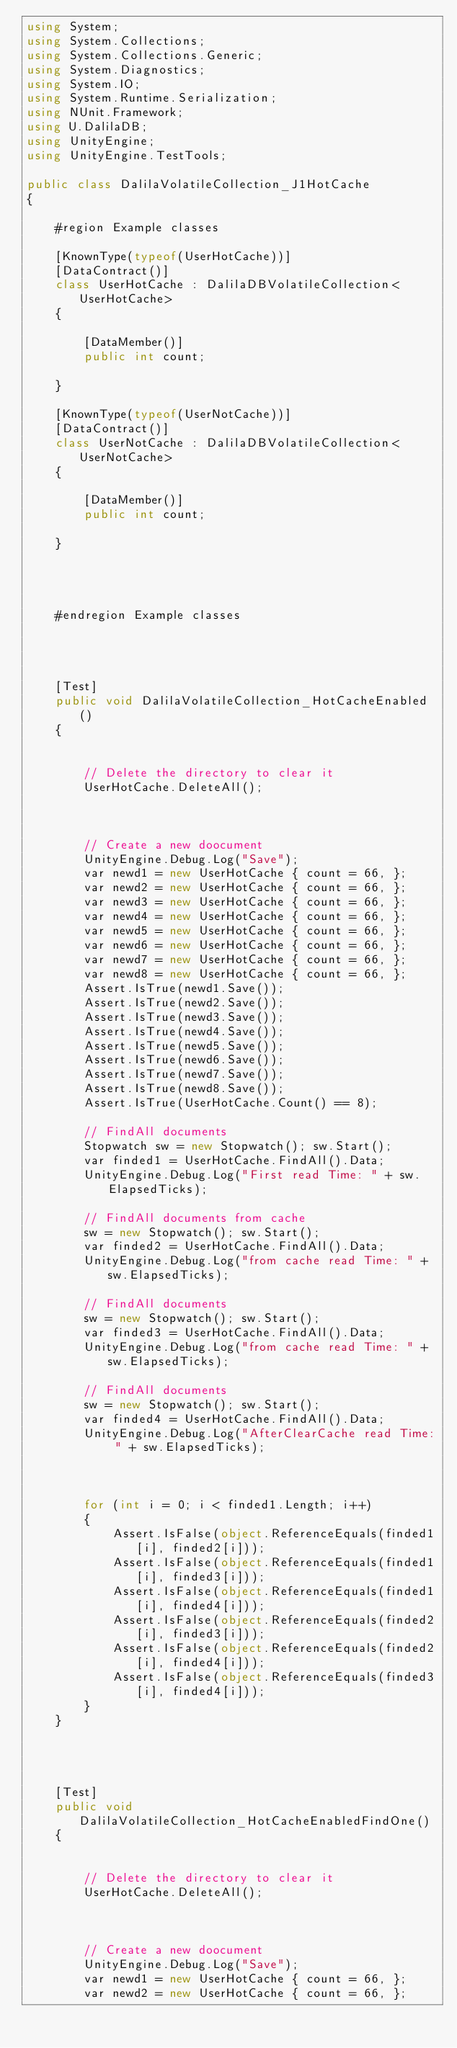<code> <loc_0><loc_0><loc_500><loc_500><_C#_>using System;
using System.Collections;
using System.Collections.Generic;
using System.Diagnostics;
using System.IO;
using System.Runtime.Serialization;
using NUnit.Framework;
using U.DalilaDB;
using UnityEngine;
using UnityEngine.TestTools;

public class DalilaVolatileCollection_J1HotCache
{

    #region Example classes

    [KnownType(typeof(UserHotCache))]
    [DataContract()]
    class UserHotCache : DalilaDBVolatileCollection<UserHotCache>
    {

        [DataMember()]
        public int count;

    }

    [KnownType(typeof(UserNotCache))]
    [DataContract()]
    class UserNotCache : DalilaDBVolatileCollection<UserNotCache>
    {

        [DataMember()]
        public int count;

    }




    #endregion Example classes




    [Test]
    public void DalilaVolatileCollection_HotCacheEnabled()
    {


        // Delete the directory to clear it
        UserHotCache.DeleteAll();



        // Create a new doocument
        UnityEngine.Debug.Log("Save");
        var newd1 = new UserHotCache { count = 66, };
        var newd2 = new UserHotCache { count = 66, };
        var newd3 = new UserHotCache { count = 66, };
        var newd4 = new UserHotCache { count = 66, };
        var newd5 = new UserHotCache { count = 66, };
        var newd6 = new UserHotCache { count = 66, };
        var newd7 = new UserHotCache { count = 66, };
        var newd8 = new UserHotCache { count = 66, };
        Assert.IsTrue(newd1.Save());
        Assert.IsTrue(newd2.Save());
        Assert.IsTrue(newd3.Save());
        Assert.IsTrue(newd4.Save());
        Assert.IsTrue(newd5.Save());
        Assert.IsTrue(newd6.Save());
        Assert.IsTrue(newd7.Save());
        Assert.IsTrue(newd8.Save());
        Assert.IsTrue(UserHotCache.Count() == 8);

        // FindAll documents
        Stopwatch sw = new Stopwatch(); sw.Start();
        var finded1 = UserHotCache.FindAll().Data;
        UnityEngine.Debug.Log("First read Time: " + sw.ElapsedTicks);

        // FindAll documents from cache
        sw = new Stopwatch(); sw.Start();
        var finded2 = UserHotCache.FindAll().Data;
        UnityEngine.Debug.Log("from cache read Time: " + sw.ElapsedTicks);

        // FindAll documents
        sw = new Stopwatch(); sw.Start();
        var finded3 = UserHotCache.FindAll().Data;
        UnityEngine.Debug.Log("from cache read Time: " + sw.ElapsedTicks);

        // FindAll documents
        sw = new Stopwatch(); sw.Start();
        var finded4 = UserHotCache.FindAll().Data;
        UnityEngine.Debug.Log("AfterClearCache read Time: " + sw.ElapsedTicks);



        for (int i = 0; i < finded1.Length; i++)
        {
            Assert.IsFalse(object.ReferenceEquals(finded1[i], finded2[i]));
            Assert.IsFalse(object.ReferenceEquals(finded1[i], finded3[i]));
            Assert.IsFalse(object.ReferenceEquals(finded1[i], finded4[i]));
            Assert.IsFalse(object.ReferenceEquals(finded2[i], finded3[i]));
            Assert.IsFalse(object.ReferenceEquals(finded2[i], finded4[i]));
            Assert.IsFalse(object.ReferenceEquals(finded3[i], finded4[i]));
        }
    }




    [Test]
    public void DalilaVolatileCollection_HotCacheEnabledFindOne()
    {


        // Delete the directory to clear it
        UserHotCache.DeleteAll();



        // Create a new doocument
        UnityEngine.Debug.Log("Save");
        var newd1 = new UserHotCache { count = 66, };
        var newd2 = new UserHotCache { count = 66, };</code> 